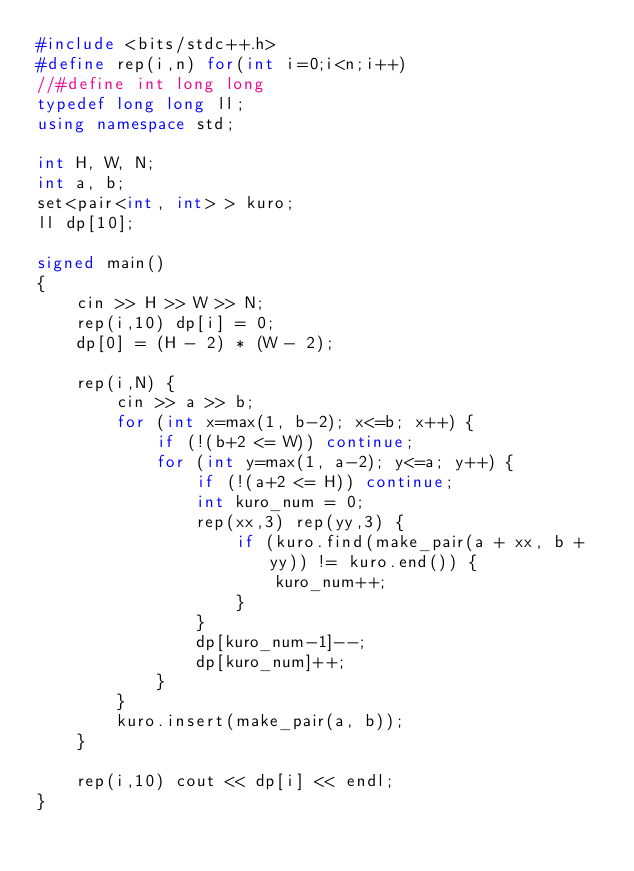Convert code to text. <code><loc_0><loc_0><loc_500><loc_500><_C++_>#include <bits/stdc++.h>
#define rep(i,n) for(int i=0;i<n;i++)
//#define int long long
typedef long long ll;
using namespace std;

int H, W, N;
int a, b;
set<pair<int, int> > kuro;
ll dp[10];

signed main()
{
	cin >> H >> W >> N;
	rep(i,10) dp[i] = 0;
	dp[0] = (H - 2) * (W - 2);

	rep(i,N) {
		cin >> a >> b;
		for (int x=max(1, b-2); x<=b; x++) {
			if (!(b+2 <= W)) continue;
			for (int y=max(1, a-2); y<=a; y++) {
				if (!(a+2 <= H)) continue;
				int kuro_num = 0;
				rep(xx,3) rep(yy,3) {
					if (kuro.find(make_pair(a + xx, b + yy)) != kuro.end()) {
						kuro_num++;
					}
				}
				dp[kuro_num-1]--;
				dp[kuro_num]++;
			}
		}
		kuro.insert(make_pair(a, b));
	}

	rep(i,10) cout << dp[i] << endl;
}
</code> 